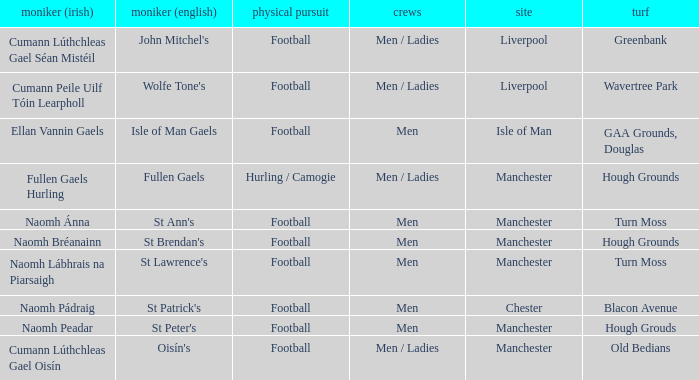What is the English Name of the Location in Chester? St Patrick's. 